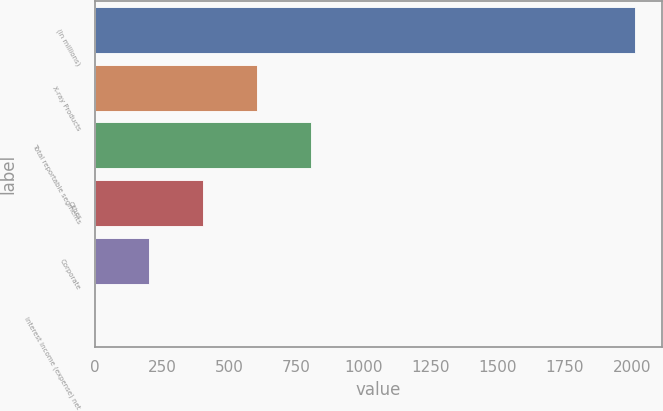<chart> <loc_0><loc_0><loc_500><loc_500><bar_chart><fcel>(In millions)<fcel>X-ray Products<fcel>Total reportable segments<fcel>Other<fcel>Corporate<fcel>Interest income (expense) net<nl><fcel>2010<fcel>603.7<fcel>804.6<fcel>402.8<fcel>201.9<fcel>1<nl></chart> 